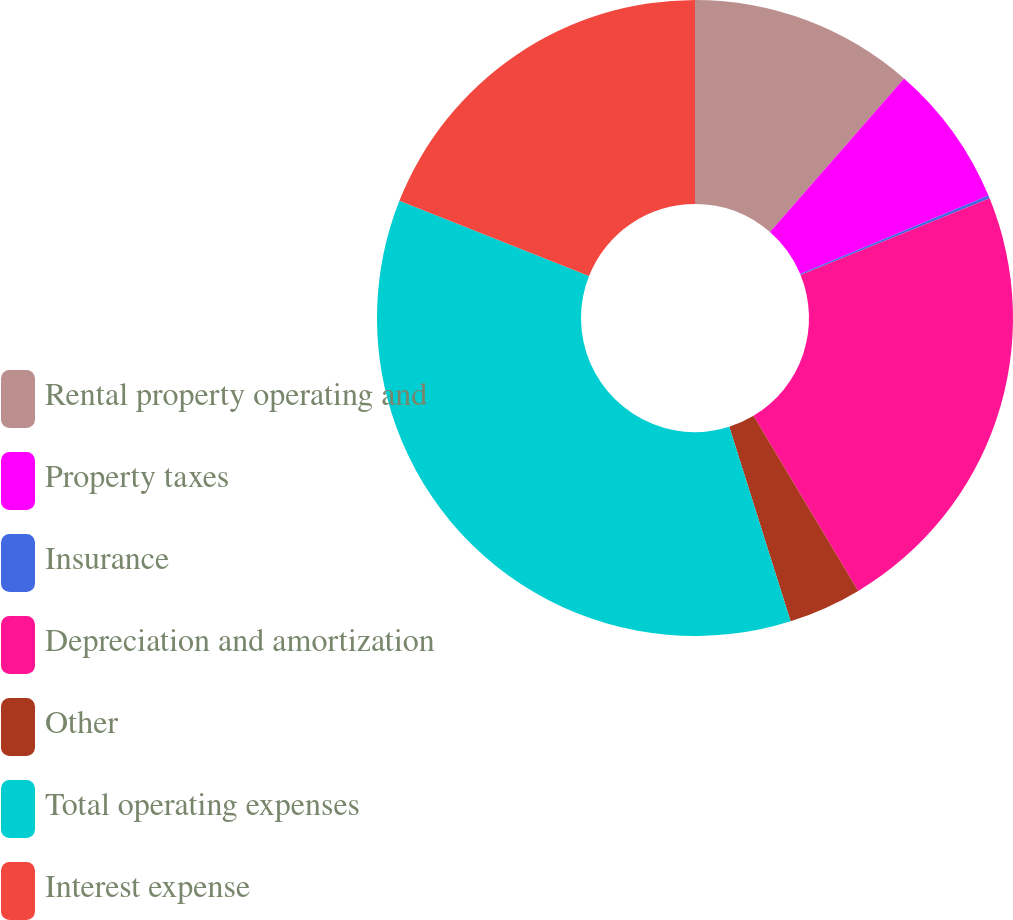Convert chart to OTSL. <chart><loc_0><loc_0><loc_500><loc_500><pie_chart><fcel>Rental property operating and<fcel>Property taxes<fcel>Insurance<fcel>Depreciation and amortization<fcel>Other<fcel>Total operating expenses<fcel>Interest expense<nl><fcel>11.42%<fcel>7.29%<fcel>0.15%<fcel>22.56%<fcel>3.72%<fcel>35.87%<fcel>18.99%<nl></chart> 